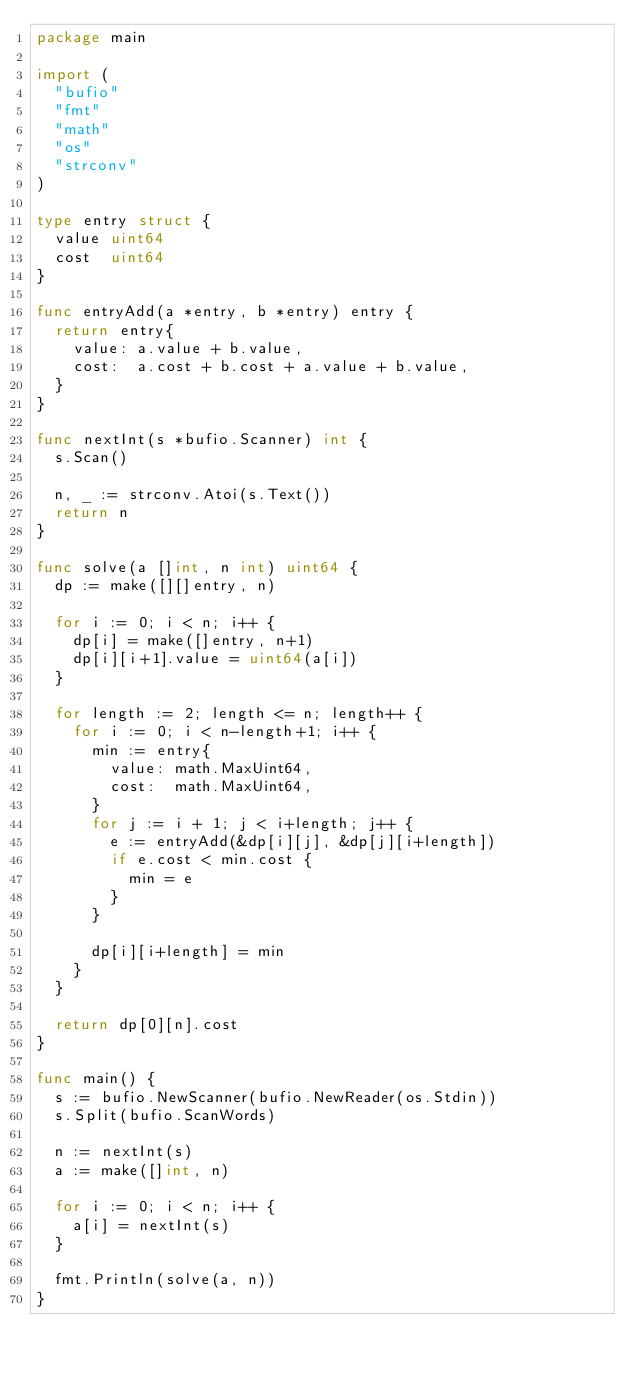Convert code to text. <code><loc_0><loc_0><loc_500><loc_500><_Go_>package main

import (
	"bufio"
	"fmt"
	"math"
	"os"
	"strconv"
)

type entry struct {
	value uint64
	cost  uint64
}

func entryAdd(a *entry, b *entry) entry {
	return entry{
		value: a.value + b.value,
		cost:  a.cost + b.cost + a.value + b.value,
	}
}

func nextInt(s *bufio.Scanner) int {
	s.Scan()

	n, _ := strconv.Atoi(s.Text())
	return n
}

func solve(a []int, n int) uint64 {
	dp := make([][]entry, n)

	for i := 0; i < n; i++ {
		dp[i] = make([]entry, n+1)
		dp[i][i+1].value = uint64(a[i])
	}

	for length := 2; length <= n; length++ {
		for i := 0; i < n-length+1; i++ {
			min := entry{
				value: math.MaxUint64,
				cost:  math.MaxUint64,
			}
			for j := i + 1; j < i+length; j++ {
				e := entryAdd(&dp[i][j], &dp[j][i+length])
				if e.cost < min.cost {
					min = e
				}
			}

			dp[i][i+length] = min
		}
	}

	return dp[0][n].cost
}

func main() {
	s := bufio.NewScanner(bufio.NewReader(os.Stdin))
	s.Split(bufio.ScanWords)

	n := nextInt(s)
	a := make([]int, n)

	for i := 0; i < n; i++ {
		a[i] = nextInt(s)
	}

	fmt.Println(solve(a, n))
}
</code> 